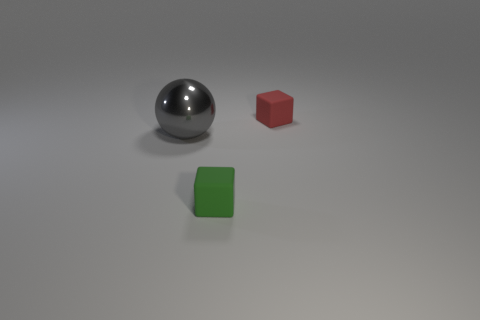Is there any other thing that is made of the same material as the gray sphere?
Offer a very short reply. No. What is the shape of the big gray metallic object that is on the left side of the small matte thing that is behind the gray object?
Provide a short and direct response. Sphere. What is the color of the other small thing that is made of the same material as the small red object?
Provide a short and direct response. Green. What is the size of the object that is right of the small rubber cube that is in front of the red matte cube on the right side of the shiny object?
Give a very brief answer. Small. Are there fewer big metal objects than large red matte cylinders?
Your answer should be very brief. No. What is the color of the other rubber thing that is the same shape as the small red rubber thing?
Offer a very short reply. Green. Are there any tiny matte blocks in front of the rubber cube that is behind the object in front of the large shiny sphere?
Keep it short and to the point. Yes. Do the tiny green matte thing and the red thing have the same shape?
Provide a succinct answer. Yes. Are there fewer green rubber things on the left side of the metallic sphere than small purple matte cylinders?
Your response must be concise. No. What color is the small rubber thing behind the tiny matte thing on the left side of the tiny thing behind the big sphere?
Provide a succinct answer. Red. 